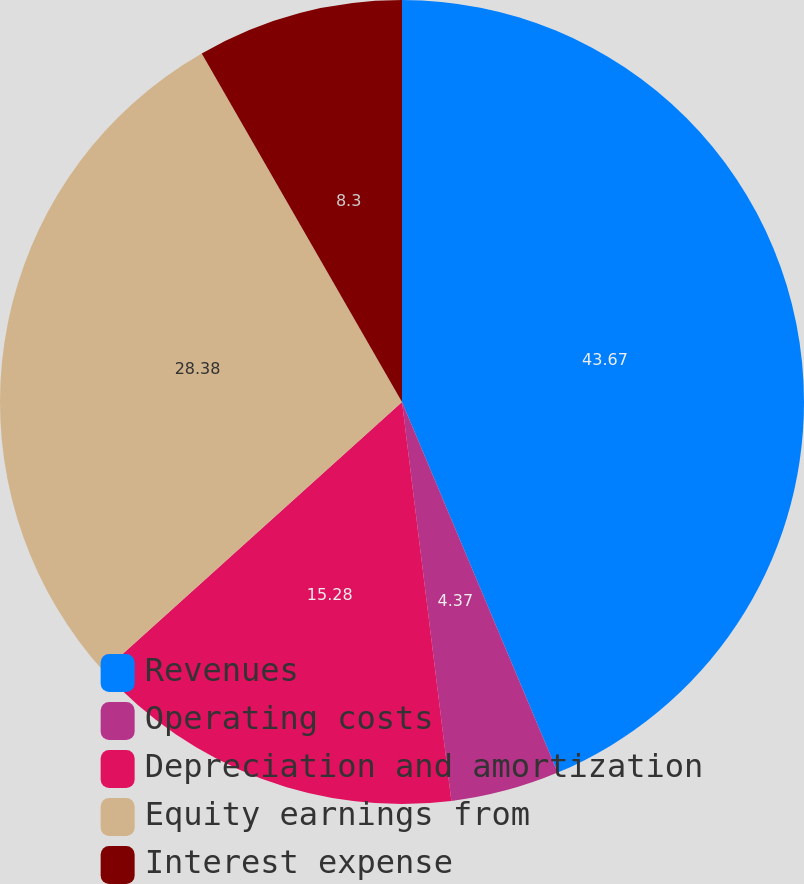<chart> <loc_0><loc_0><loc_500><loc_500><pie_chart><fcel>Revenues<fcel>Operating costs<fcel>Depreciation and amortization<fcel>Equity earnings from<fcel>Interest expense<nl><fcel>43.67%<fcel>4.37%<fcel>15.28%<fcel>28.38%<fcel>8.3%<nl></chart> 